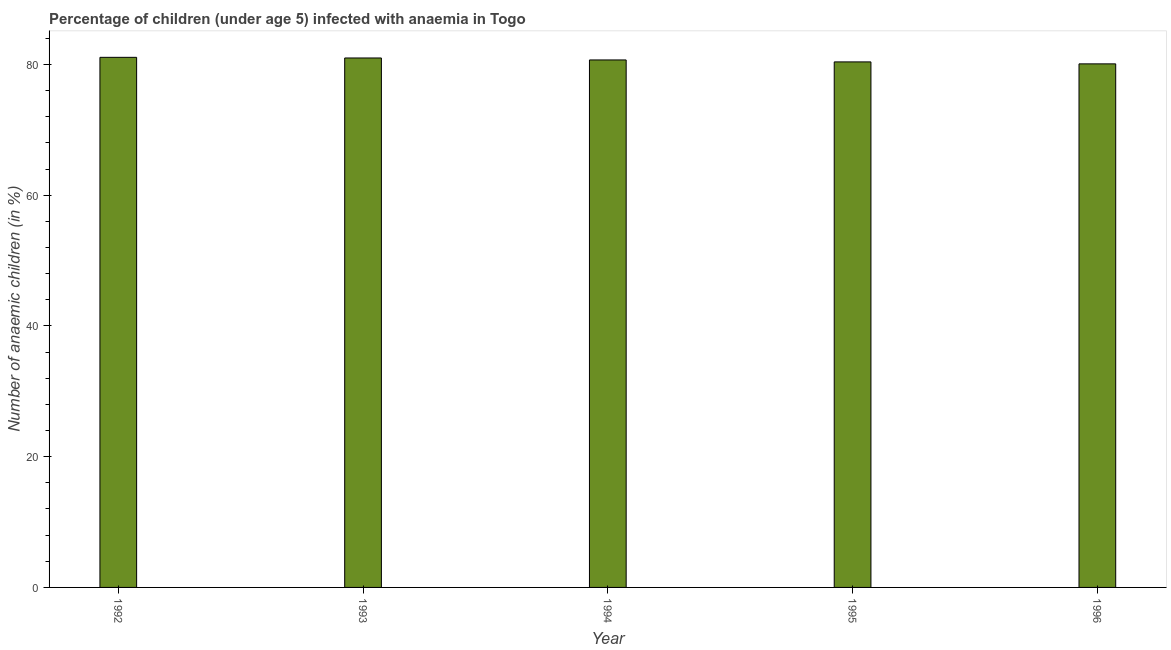What is the title of the graph?
Your response must be concise. Percentage of children (under age 5) infected with anaemia in Togo. What is the label or title of the X-axis?
Your answer should be very brief. Year. What is the label or title of the Y-axis?
Provide a succinct answer. Number of anaemic children (in %). What is the number of anaemic children in 1992?
Your response must be concise. 81.1. Across all years, what is the maximum number of anaemic children?
Provide a succinct answer. 81.1. Across all years, what is the minimum number of anaemic children?
Keep it short and to the point. 80.1. In which year was the number of anaemic children minimum?
Your answer should be very brief. 1996. What is the sum of the number of anaemic children?
Provide a short and direct response. 403.3. What is the average number of anaemic children per year?
Make the answer very short. 80.66. What is the median number of anaemic children?
Offer a terse response. 80.7. In how many years, is the number of anaemic children greater than 16 %?
Give a very brief answer. 5. What is the difference between the highest and the second highest number of anaemic children?
Make the answer very short. 0.1. Is the sum of the number of anaemic children in 1992 and 1995 greater than the maximum number of anaemic children across all years?
Give a very brief answer. Yes. What is the difference between two consecutive major ticks on the Y-axis?
Your response must be concise. 20. What is the Number of anaemic children (in %) of 1992?
Provide a succinct answer. 81.1. What is the Number of anaemic children (in %) of 1993?
Make the answer very short. 81. What is the Number of anaemic children (in %) in 1994?
Your answer should be compact. 80.7. What is the Number of anaemic children (in %) of 1995?
Keep it short and to the point. 80.4. What is the Number of anaemic children (in %) of 1996?
Your answer should be very brief. 80.1. What is the difference between the Number of anaemic children (in %) in 1992 and 1994?
Ensure brevity in your answer.  0.4. What is the difference between the Number of anaemic children (in %) in 1992 and 1996?
Your answer should be compact. 1. What is the difference between the Number of anaemic children (in %) in 1993 and 1994?
Offer a terse response. 0.3. What is the difference between the Number of anaemic children (in %) in 1994 and 1996?
Your answer should be compact. 0.6. What is the ratio of the Number of anaemic children (in %) in 1992 to that in 1993?
Offer a very short reply. 1. What is the ratio of the Number of anaemic children (in %) in 1992 to that in 1994?
Ensure brevity in your answer.  1. What is the ratio of the Number of anaemic children (in %) in 1992 to that in 1996?
Provide a short and direct response. 1.01. What is the ratio of the Number of anaemic children (in %) in 1993 to that in 1996?
Keep it short and to the point. 1.01. What is the ratio of the Number of anaemic children (in %) in 1994 to that in 1995?
Provide a short and direct response. 1. 